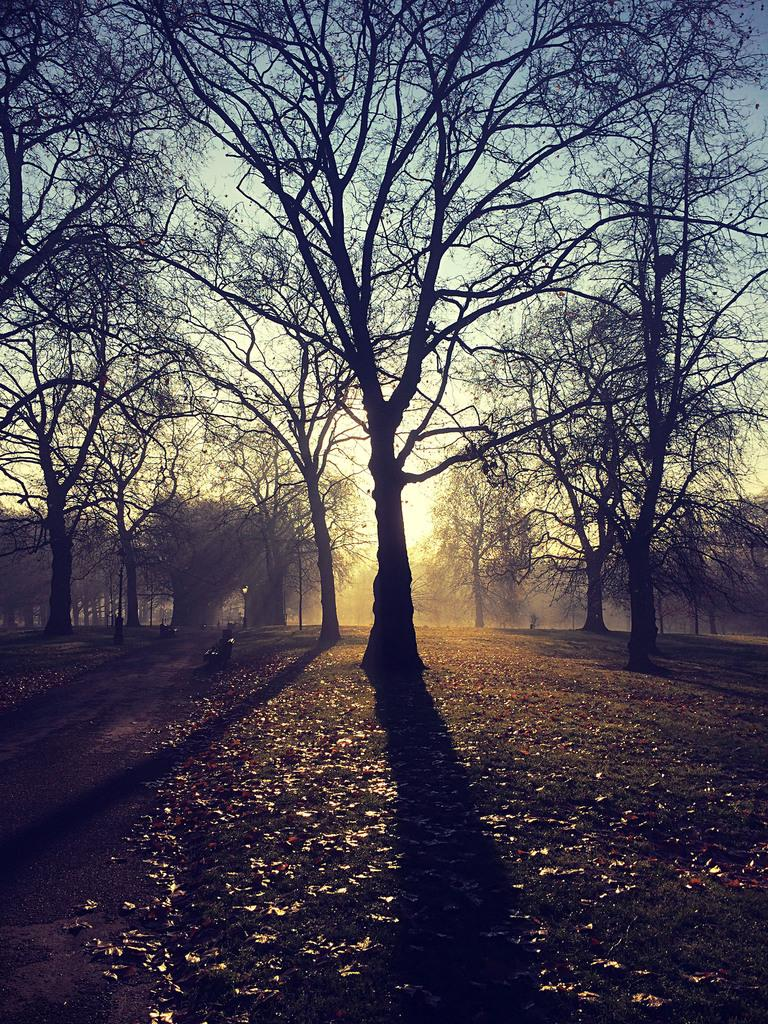What type of vegetation can be seen in the image? There are trees in the image. What is visible in the background of the image? The sky is visible in the image. What is the source of light in the image? Sunlight is present in the image. Can you see any cracks in the self in the image? There is no self present in the image, and therefore no cracks can be observed. 